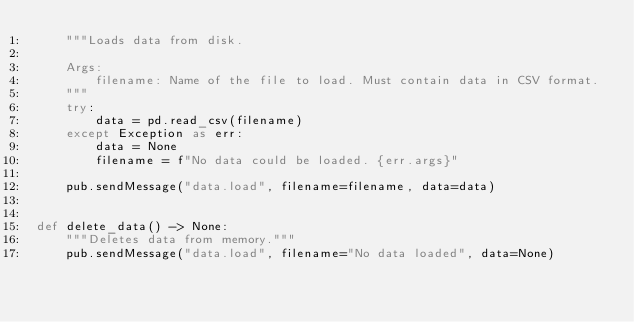<code> <loc_0><loc_0><loc_500><loc_500><_Python_>    """Loads data from disk.

    Args:
        filename: Name of the file to load. Must contain data in CSV format.
    """
    try:
        data = pd.read_csv(filename)
    except Exception as err:
        data = None
        filename = f"No data could be loaded. {err.args}"

    pub.sendMessage("data.load", filename=filename, data=data)


def delete_data() -> None:
    """Deletes data from memory."""
    pub.sendMessage("data.load", filename="No data loaded", data=None)
</code> 